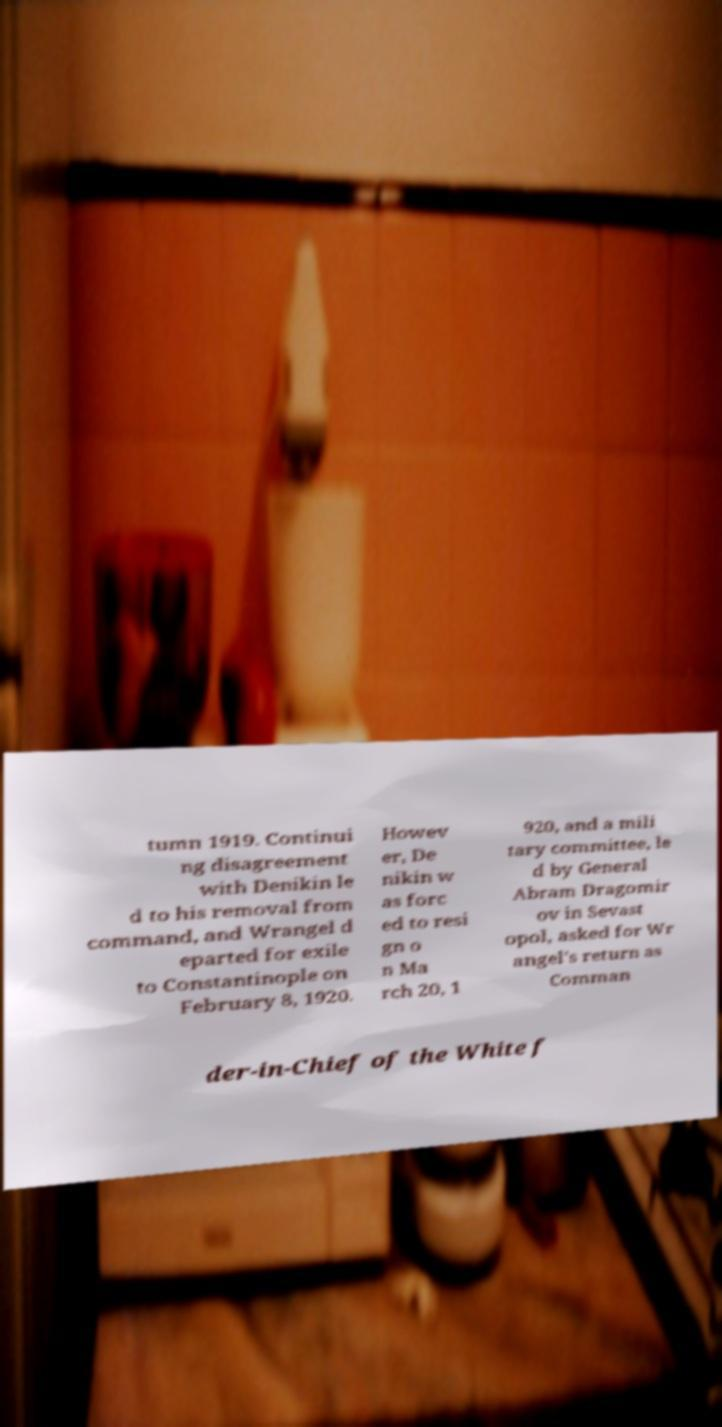Please read and relay the text visible in this image. What does it say? tumn 1919. Continui ng disagreement with Denikin le d to his removal from command, and Wrangel d eparted for exile to Constantinople on February 8, 1920. Howev er, De nikin w as forc ed to resi gn o n Ma rch 20, 1 920, and a mili tary committee, le d by General Abram Dragomir ov in Sevast opol, asked for Wr angel's return as Comman der-in-Chief of the White f 